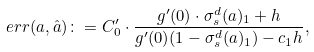Convert formula to latex. <formula><loc_0><loc_0><loc_500><loc_500>\ e r r ( a , \hat { a } ) \colon = C _ { 0 } ^ { \prime } \cdot \frac { g ^ { \prime } ( 0 ) \cdot \sigma _ { s } ^ { d } ( a ) _ { 1 } + h } { g ^ { \prime } ( 0 ) ( 1 - \sigma _ { s } ^ { d } ( a ) _ { 1 } ) - c _ { 1 } h } ,</formula> 